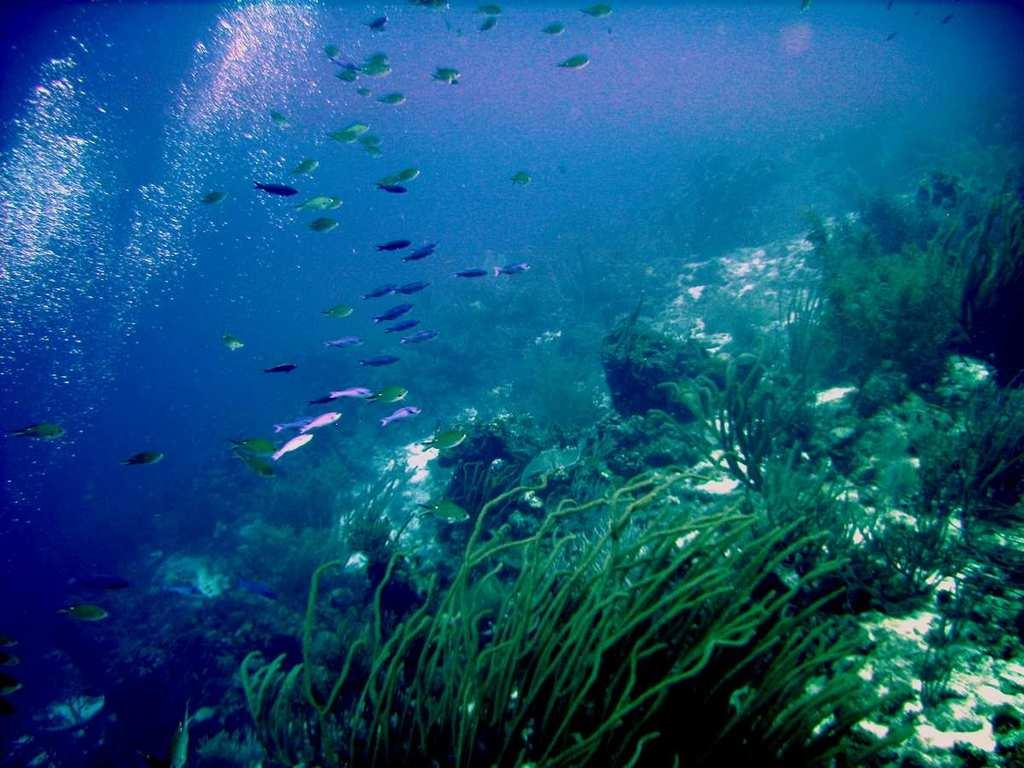What type of animals can be seen in the image? There are fishes in the image. What other elements can be seen in the image besides the fishes? There are rocks, corals, and reefs in the image. What is the setting of the image? All these elements are underwater. Can you see any apples floating in the water in the image? There are no apples present in the image; it features underwater elements such as fishes, rocks, corals, and reefs. 